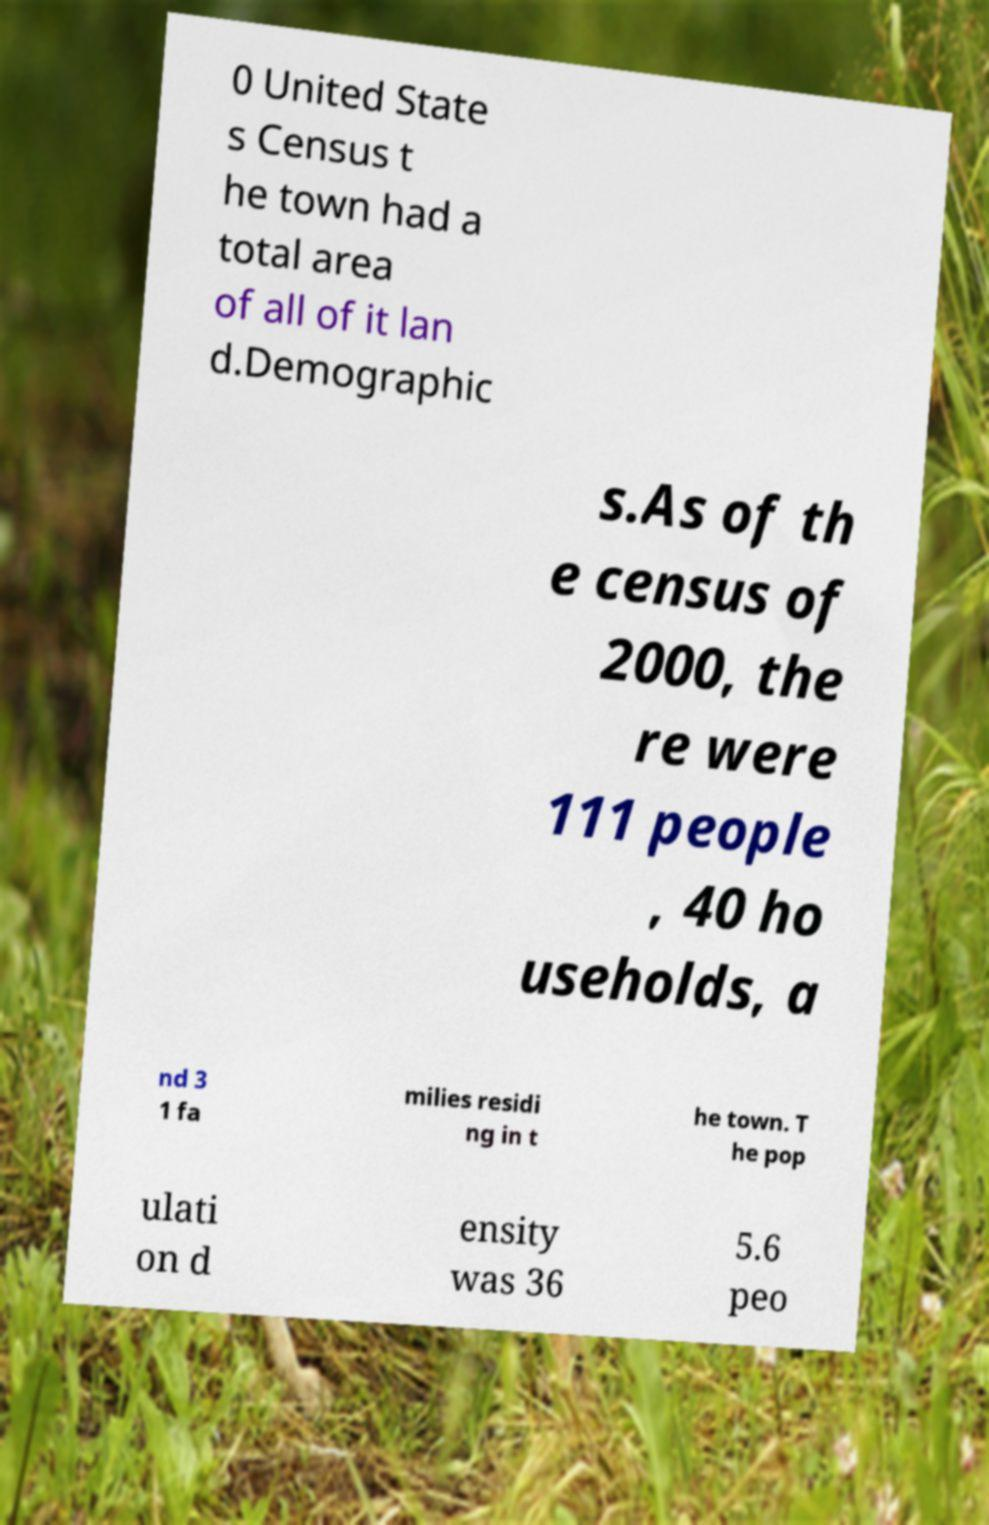Can you read and provide the text displayed in the image?This photo seems to have some interesting text. Can you extract and type it out for me? 0 United State s Census t he town had a total area of all of it lan d.Demographic s.As of th e census of 2000, the re were 111 people , 40 ho useholds, a nd 3 1 fa milies residi ng in t he town. T he pop ulati on d ensity was 36 5.6 peo 